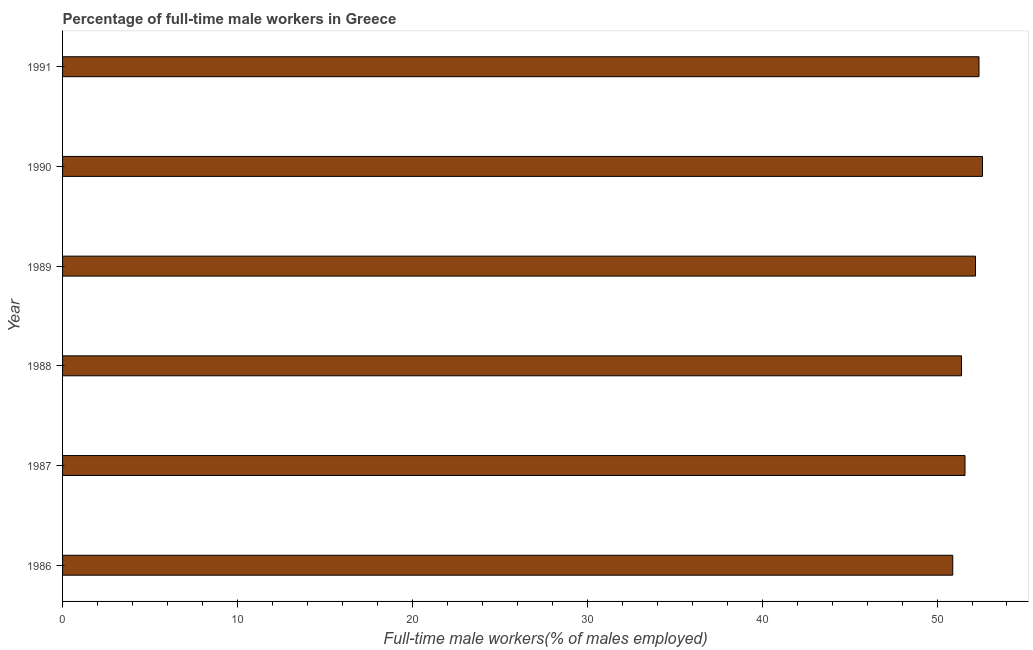What is the title of the graph?
Provide a short and direct response. Percentage of full-time male workers in Greece. What is the label or title of the X-axis?
Give a very brief answer. Full-time male workers(% of males employed). What is the label or title of the Y-axis?
Your response must be concise. Year. What is the percentage of full-time male workers in 1990?
Offer a terse response. 52.6. Across all years, what is the maximum percentage of full-time male workers?
Your answer should be very brief. 52.6. Across all years, what is the minimum percentage of full-time male workers?
Offer a terse response. 50.9. What is the sum of the percentage of full-time male workers?
Provide a succinct answer. 311.1. What is the difference between the percentage of full-time male workers in 1986 and 1987?
Offer a very short reply. -0.7. What is the average percentage of full-time male workers per year?
Your answer should be compact. 51.85. What is the median percentage of full-time male workers?
Ensure brevity in your answer.  51.9. What is the ratio of the percentage of full-time male workers in 1988 to that in 1991?
Your answer should be compact. 0.98. What is the difference between the highest and the second highest percentage of full-time male workers?
Offer a terse response. 0.2. What is the difference between the highest and the lowest percentage of full-time male workers?
Ensure brevity in your answer.  1.7. In how many years, is the percentage of full-time male workers greater than the average percentage of full-time male workers taken over all years?
Offer a very short reply. 3. How many bars are there?
Ensure brevity in your answer.  6. How many years are there in the graph?
Your answer should be compact. 6. What is the difference between two consecutive major ticks on the X-axis?
Your answer should be very brief. 10. What is the Full-time male workers(% of males employed) of 1986?
Provide a short and direct response. 50.9. What is the Full-time male workers(% of males employed) in 1987?
Your answer should be compact. 51.6. What is the Full-time male workers(% of males employed) in 1988?
Make the answer very short. 51.4. What is the Full-time male workers(% of males employed) in 1989?
Keep it short and to the point. 52.2. What is the Full-time male workers(% of males employed) of 1990?
Provide a short and direct response. 52.6. What is the Full-time male workers(% of males employed) in 1991?
Your answer should be very brief. 52.4. What is the difference between the Full-time male workers(% of males employed) in 1986 and 1988?
Your answer should be very brief. -0.5. What is the difference between the Full-time male workers(% of males employed) in 1986 and 1989?
Your answer should be compact. -1.3. What is the difference between the Full-time male workers(% of males employed) in 1987 and 1988?
Keep it short and to the point. 0.2. What is the difference between the Full-time male workers(% of males employed) in 1987 and 1989?
Your response must be concise. -0.6. What is the difference between the Full-time male workers(% of males employed) in 1988 and 1989?
Provide a succinct answer. -0.8. What is the difference between the Full-time male workers(% of males employed) in 1988 and 1990?
Keep it short and to the point. -1.2. What is the difference between the Full-time male workers(% of males employed) in 1988 and 1991?
Offer a very short reply. -1. What is the difference between the Full-time male workers(% of males employed) in 1989 and 1991?
Provide a succinct answer. -0.2. What is the ratio of the Full-time male workers(% of males employed) in 1986 to that in 1989?
Your answer should be very brief. 0.97. What is the ratio of the Full-time male workers(% of males employed) in 1986 to that in 1990?
Provide a short and direct response. 0.97. What is the ratio of the Full-time male workers(% of males employed) in 1987 to that in 1988?
Ensure brevity in your answer.  1. What is the ratio of the Full-time male workers(% of males employed) in 1987 to that in 1989?
Keep it short and to the point. 0.99. What is the ratio of the Full-time male workers(% of males employed) in 1987 to that in 1990?
Your response must be concise. 0.98. What is the ratio of the Full-time male workers(% of males employed) in 1990 to that in 1991?
Give a very brief answer. 1. 